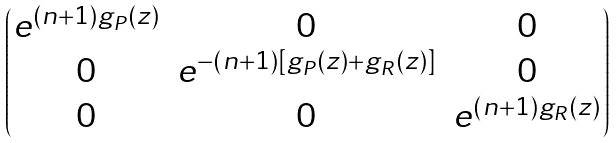<formula> <loc_0><loc_0><loc_500><loc_500>\begin{pmatrix} e ^ { ( n + 1 ) g _ { P } ( z ) } & 0 & 0 \\ 0 & e ^ { - ( n + 1 ) [ g _ { P } ( z ) + g _ { R } ( z ) ] } & 0 \\ 0 & 0 & e ^ { ( n + 1 ) g _ { R } ( z ) } \end{pmatrix}</formula> 